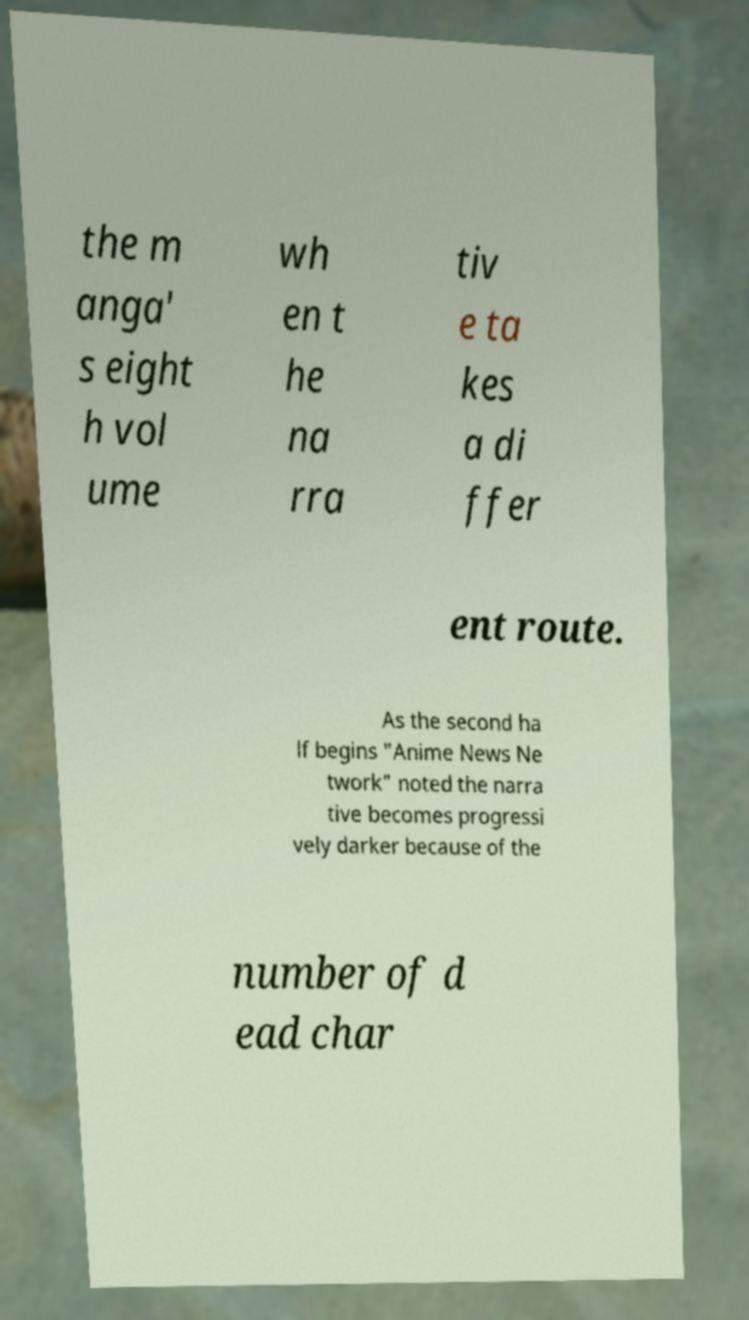Could you assist in decoding the text presented in this image and type it out clearly? the m anga' s eight h vol ume wh en t he na rra tiv e ta kes a di ffer ent route. As the second ha lf begins "Anime News Ne twork" noted the narra tive becomes progressi vely darker because of the number of d ead char 